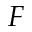Convert formula to latex. <formula><loc_0><loc_0><loc_500><loc_500>F</formula> 